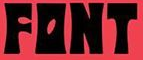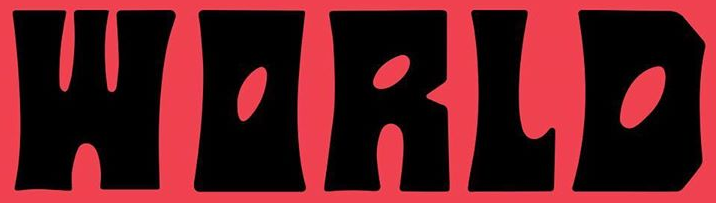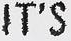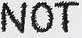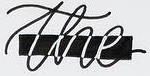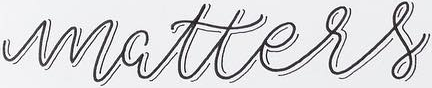What text is displayed in these images sequentially, separated by a semicolon? FONT; WORLD; IT'S; NOT; the; matters 